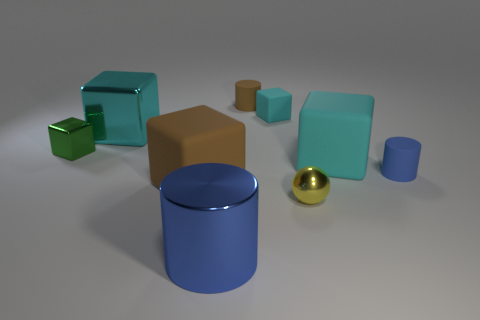There is a large thing to the right of the large thing that is in front of the brown cube; are there any small cyan things that are on the right side of it?
Make the answer very short. No. What size is the blue metal cylinder?
Your answer should be compact. Large. There is a brown matte object in front of the large cyan metallic thing; what is its size?
Make the answer very short. Large. There is a brown rubber thing that is in front of the green block; does it have the same size as the big blue shiny cylinder?
Offer a very short reply. Yes. Is there anything else that has the same color as the metal ball?
Offer a very short reply. No. What is the shape of the small brown thing?
Your answer should be very brief. Cylinder. What number of things are both on the left side of the large cyan shiny block and right of the tiny cyan matte object?
Your answer should be compact. 0. Does the tiny rubber block have the same color as the big metallic cube?
Provide a succinct answer. Yes. What material is the brown object that is the same shape as the big blue shiny object?
Provide a succinct answer. Rubber. Is the number of big cyan blocks in front of the large metallic block the same as the number of big cylinders that are behind the shiny cylinder?
Your answer should be very brief. No. 